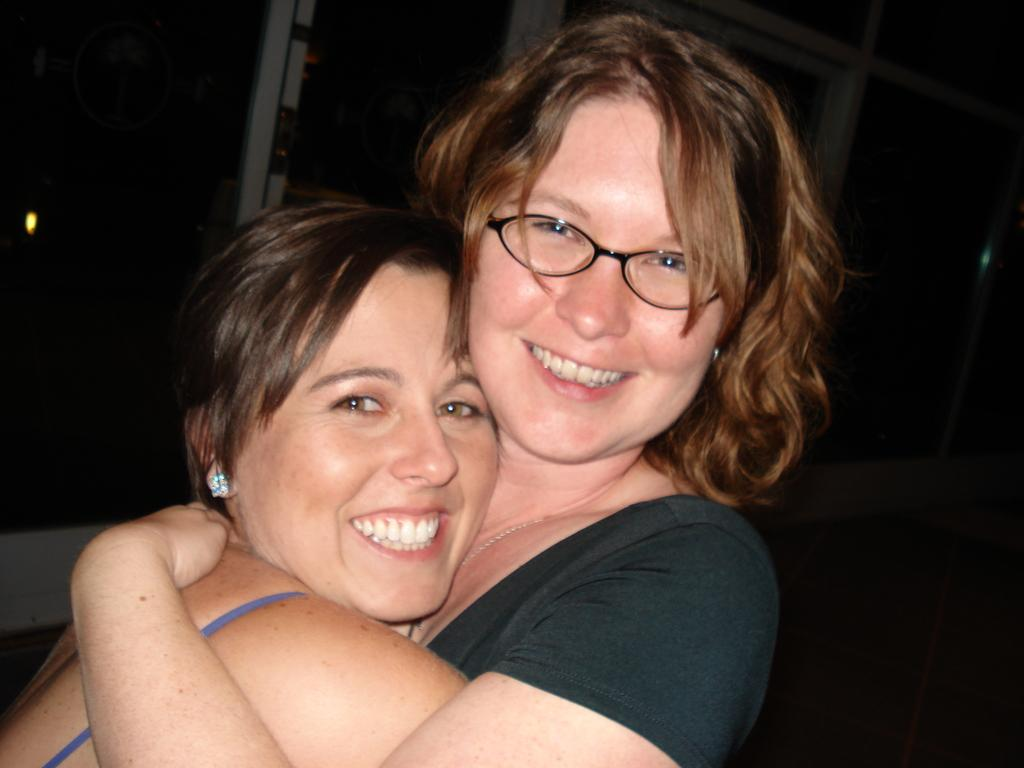Who is present in the image? There are women in the image. What expression do the women have? The women are smiling. How many babies are visible in the image? There are no babies present in the image; it features women who are smiling. What type of dress is the woman wearing on her legs? There is no specific dress mentioned in the image, and the women's legs are not described. 